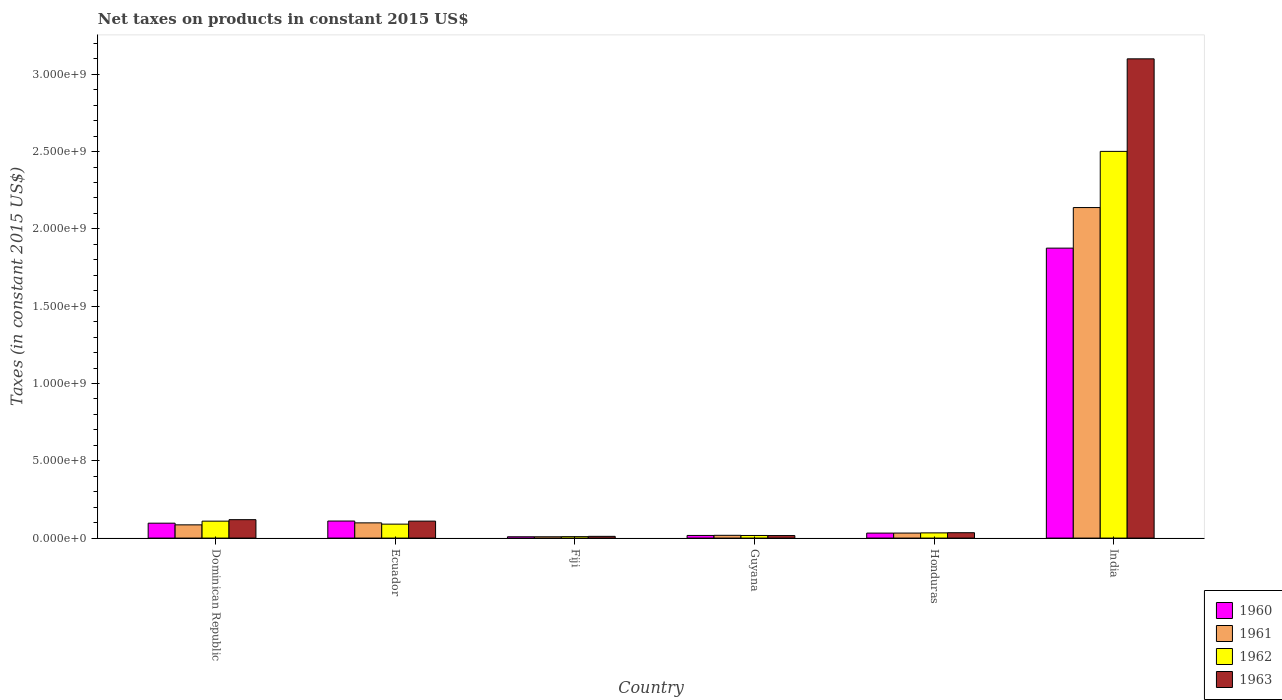How many different coloured bars are there?
Your answer should be compact. 4. How many groups of bars are there?
Your response must be concise. 6. Are the number of bars on each tick of the X-axis equal?
Provide a succinct answer. Yes. What is the label of the 5th group of bars from the left?
Provide a succinct answer. Honduras. In how many cases, is the number of bars for a given country not equal to the number of legend labels?
Provide a short and direct response. 0. What is the net taxes on products in 1962 in Fiji?
Give a very brief answer. 9.32e+06. Across all countries, what is the maximum net taxes on products in 1960?
Make the answer very short. 1.88e+09. Across all countries, what is the minimum net taxes on products in 1961?
Give a very brief answer. 8.56e+06. In which country was the net taxes on products in 1963 minimum?
Ensure brevity in your answer.  Fiji. What is the total net taxes on products in 1960 in the graph?
Make the answer very short. 2.14e+09. What is the difference between the net taxes on products in 1962 in Guyana and that in Honduras?
Provide a succinct answer. -1.67e+07. What is the difference between the net taxes on products in 1960 in Honduras and the net taxes on products in 1961 in Fiji?
Provide a short and direct response. 2.37e+07. What is the average net taxes on products in 1960 per country?
Provide a succinct answer. 3.57e+08. What is the difference between the net taxes on products of/in 1960 and net taxes on products of/in 1963 in Ecuador?
Your response must be concise. 5.57e+05. What is the ratio of the net taxes on products in 1962 in Dominican Republic to that in Fiji?
Provide a succinct answer. 11.76. Is the net taxes on products in 1960 in Fiji less than that in Guyana?
Offer a terse response. Yes. Is the difference between the net taxes on products in 1960 in Fiji and Honduras greater than the difference between the net taxes on products in 1963 in Fiji and Honduras?
Your answer should be very brief. No. What is the difference between the highest and the second highest net taxes on products in 1960?
Provide a succinct answer. -1.78e+09. What is the difference between the highest and the lowest net taxes on products in 1962?
Your answer should be very brief. 2.49e+09. What does the 4th bar from the right in Dominican Republic represents?
Your answer should be very brief. 1960. How many countries are there in the graph?
Provide a short and direct response. 6. What is the difference between two consecutive major ticks on the Y-axis?
Make the answer very short. 5.00e+08. Are the values on the major ticks of Y-axis written in scientific E-notation?
Make the answer very short. Yes. Does the graph contain grids?
Offer a very short reply. No. How are the legend labels stacked?
Your answer should be compact. Vertical. What is the title of the graph?
Offer a terse response. Net taxes on products in constant 2015 US$. Does "1980" appear as one of the legend labels in the graph?
Offer a terse response. No. What is the label or title of the Y-axis?
Offer a terse response. Taxes (in constant 2015 US$). What is the Taxes (in constant 2015 US$) in 1960 in Dominican Republic?
Offer a very short reply. 9.64e+07. What is the Taxes (in constant 2015 US$) in 1961 in Dominican Republic?
Provide a short and direct response. 8.56e+07. What is the Taxes (in constant 2015 US$) in 1962 in Dominican Republic?
Offer a very short reply. 1.10e+08. What is the Taxes (in constant 2015 US$) in 1963 in Dominican Republic?
Offer a terse response. 1.19e+08. What is the Taxes (in constant 2015 US$) of 1960 in Ecuador?
Provide a succinct answer. 1.10e+08. What is the Taxes (in constant 2015 US$) in 1961 in Ecuador?
Provide a short and direct response. 9.85e+07. What is the Taxes (in constant 2015 US$) in 1962 in Ecuador?
Ensure brevity in your answer.  9.03e+07. What is the Taxes (in constant 2015 US$) in 1963 in Ecuador?
Ensure brevity in your answer.  1.10e+08. What is the Taxes (in constant 2015 US$) of 1960 in Fiji?
Make the answer very short. 8.56e+06. What is the Taxes (in constant 2015 US$) of 1961 in Fiji?
Offer a very short reply. 8.56e+06. What is the Taxes (in constant 2015 US$) of 1962 in Fiji?
Your answer should be very brief. 9.32e+06. What is the Taxes (in constant 2015 US$) of 1963 in Fiji?
Give a very brief answer. 1.12e+07. What is the Taxes (in constant 2015 US$) of 1960 in Guyana?
Give a very brief answer. 1.71e+07. What is the Taxes (in constant 2015 US$) in 1961 in Guyana?
Keep it short and to the point. 1.79e+07. What is the Taxes (in constant 2015 US$) of 1962 in Guyana?
Provide a short and direct response. 1.69e+07. What is the Taxes (in constant 2015 US$) of 1963 in Guyana?
Offer a very short reply. 1.64e+07. What is the Taxes (in constant 2015 US$) of 1960 in Honduras?
Ensure brevity in your answer.  3.22e+07. What is the Taxes (in constant 2015 US$) in 1961 in Honduras?
Your response must be concise. 3.25e+07. What is the Taxes (in constant 2015 US$) in 1962 in Honduras?
Make the answer very short. 3.36e+07. What is the Taxes (in constant 2015 US$) of 1963 in Honduras?
Offer a terse response. 3.48e+07. What is the Taxes (in constant 2015 US$) of 1960 in India?
Make the answer very short. 1.88e+09. What is the Taxes (in constant 2015 US$) of 1961 in India?
Make the answer very short. 2.14e+09. What is the Taxes (in constant 2015 US$) of 1962 in India?
Give a very brief answer. 2.50e+09. What is the Taxes (in constant 2015 US$) in 1963 in India?
Keep it short and to the point. 3.10e+09. Across all countries, what is the maximum Taxes (in constant 2015 US$) of 1960?
Your response must be concise. 1.88e+09. Across all countries, what is the maximum Taxes (in constant 2015 US$) in 1961?
Make the answer very short. 2.14e+09. Across all countries, what is the maximum Taxes (in constant 2015 US$) in 1962?
Provide a succinct answer. 2.50e+09. Across all countries, what is the maximum Taxes (in constant 2015 US$) of 1963?
Provide a short and direct response. 3.10e+09. Across all countries, what is the minimum Taxes (in constant 2015 US$) of 1960?
Make the answer very short. 8.56e+06. Across all countries, what is the minimum Taxes (in constant 2015 US$) in 1961?
Give a very brief answer. 8.56e+06. Across all countries, what is the minimum Taxes (in constant 2015 US$) in 1962?
Offer a very short reply. 9.32e+06. Across all countries, what is the minimum Taxes (in constant 2015 US$) of 1963?
Keep it short and to the point. 1.12e+07. What is the total Taxes (in constant 2015 US$) of 1960 in the graph?
Provide a succinct answer. 2.14e+09. What is the total Taxes (in constant 2015 US$) in 1961 in the graph?
Provide a succinct answer. 2.38e+09. What is the total Taxes (in constant 2015 US$) in 1962 in the graph?
Your answer should be compact. 2.76e+09. What is the total Taxes (in constant 2015 US$) in 1963 in the graph?
Provide a succinct answer. 3.39e+09. What is the difference between the Taxes (in constant 2015 US$) in 1960 in Dominican Republic and that in Ecuador?
Your response must be concise. -1.39e+07. What is the difference between the Taxes (in constant 2015 US$) of 1961 in Dominican Republic and that in Ecuador?
Your answer should be compact. -1.29e+07. What is the difference between the Taxes (in constant 2015 US$) in 1962 in Dominican Republic and that in Ecuador?
Keep it short and to the point. 1.93e+07. What is the difference between the Taxes (in constant 2015 US$) in 1963 in Dominican Republic and that in Ecuador?
Provide a succinct answer. 9.44e+06. What is the difference between the Taxes (in constant 2015 US$) in 1960 in Dominican Republic and that in Fiji?
Make the answer very short. 8.78e+07. What is the difference between the Taxes (in constant 2015 US$) in 1961 in Dominican Republic and that in Fiji?
Give a very brief answer. 7.70e+07. What is the difference between the Taxes (in constant 2015 US$) of 1962 in Dominican Republic and that in Fiji?
Give a very brief answer. 1.00e+08. What is the difference between the Taxes (in constant 2015 US$) in 1963 in Dominican Republic and that in Fiji?
Provide a short and direct response. 1.08e+08. What is the difference between the Taxes (in constant 2015 US$) of 1960 in Dominican Republic and that in Guyana?
Offer a terse response. 7.93e+07. What is the difference between the Taxes (in constant 2015 US$) in 1961 in Dominican Republic and that in Guyana?
Give a very brief answer. 6.77e+07. What is the difference between the Taxes (in constant 2015 US$) in 1962 in Dominican Republic and that in Guyana?
Keep it short and to the point. 9.27e+07. What is the difference between the Taxes (in constant 2015 US$) in 1963 in Dominican Republic and that in Guyana?
Your response must be concise. 1.03e+08. What is the difference between the Taxes (in constant 2015 US$) of 1960 in Dominican Republic and that in Honduras?
Your response must be concise. 6.42e+07. What is the difference between the Taxes (in constant 2015 US$) of 1961 in Dominican Republic and that in Honduras?
Offer a terse response. 5.31e+07. What is the difference between the Taxes (in constant 2015 US$) of 1962 in Dominican Republic and that in Honduras?
Your answer should be very brief. 7.60e+07. What is the difference between the Taxes (in constant 2015 US$) in 1963 in Dominican Republic and that in Honduras?
Offer a very short reply. 8.44e+07. What is the difference between the Taxes (in constant 2015 US$) in 1960 in Dominican Republic and that in India?
Make the answer very short. -1.78e+09. What is the difference between the Taxes (in constant 2015 US$) in 1961 in Dominican Republic and that in India?
Your response must be concise. -2.05e+09. What is the difference between the Taxes (in constant 2015 US$) in 1962 in Dominican Republic and that in India?
Give a very brief answer. -2.39e+09. What is the difference between the Taxes (in constant 2015 US$) of 1963 in Dominican Republic and that in India?
Provide a short and direct response. -2.98e+09. What is the difference between the Taxes (in constant 2015 US$) in 1960 in Ecuador and that in Fiji?
Your answer should be very brief. 1.02e+08. What is the difference between the Taxes (in constant 2015 US$) in 1961 in Ecuador and that in Fiji?
Keep it short and to the point. 8.99e+07. What is the difference between the Taxes (in constant 2015 US$) in 1962 in Ecuador and that in Fiji?
Offer a terse response. 8.09e+07. What is the difference between the Taxes (in constant 2015 US$) of 1963 in Ecuador and that in Fiji?
Ensure brevity in your answer.  9.86e+07. What is the difference between the Taxes (in constant 2015 US$) in 1960 in Ecuador and that in Guyana?
Offer a very short reply. 9.32e+07. What is the difference between the Taxes (in constant 2015 US$) of 1961 in Ecuador and that in Guyana?
Keep it short and to the point. 8.06e+07. What is the difference between the Taxes (in constant 2015 US$) of 1962 in Ecuador and that in Guyana?
Offer a terse response. 7.33e+07. What is the difference between the Taxes (in constant 2015 US$) in 1963 in Ecuador and that in Guyana?
Provide a succinct answer. 9.33e+07. What is the difference between the Taxes (in constant 2015 US$) in 1960 in Ecuador and that in Honduras?
Provide a short and direct response. 7.81e+07. What is the difference between the Taxes (in constant 2015 US$) in 1961 in Ecuador and that in Honduras?
Offer a very short reply. 6.60e+07. What is the difference between the Taxes (in constant 2015 US$) in 1962 in Ecuador and that in Honduras?
Your answer should be very brief. 5.66e+07. What is the difference between the Taxes (in constant 2015 US$) in 1963 in Ecuador and that in Honduras?
Your answer should be compact. 7.50e+07. What is the difference between the Taxes (in constant 2015 US$) in 1960 in Ecuador and that in India?
Offer a terse response. -1.76e+09. What is the difference between the Taxes (in constant 2015 US$) of 1961 in Ecuador and that in India?
Your answer should be compact. -2.04e+09. What is the difference between the Taxes (in constant 2015 US$) of 1962 in Ecuador and that in India?
Offer a terse response. -2.41e+09. What is the difference between the Taxes (in constant 2015 US$) in 1963 in Ecuador and that in India?
Provide a short and direct response. -2.99e+09. What is the difference between the Taxes (in constant 2015 US$) in 1960 in Fiji and that in Guyana?
Your answer should be compact. -8.59e+06. What is the difference between the Taxes (in constant 2015 US$) of 1961 in Fiji and that in Guyana?
Ensure brevity in your answer.  -9.34e+06. What is the difference between the Taxes (in constant 2015 US$) of 1962 in Fiji and that in Guyana?
Offer a very short reply. -7.60e+06. What is the difference between the Taxes (in constant 2015 US$) of 1963 in Fiji and that in Guyana?
Ensure brevity in your answer.  -5.24e+06. What is the difference between the Taxes (in constant 2015 US$) of 1960 in Fiji and that in Honduras?
Give a very brief answer. -2.37e+07. What is the difference between the Taxes (in constant 2015 US$) in 1961 in Fiji and that in Honduras?
Offer a terse response. -2.39e+07. What is the difference between the Taxes (in constant 2015 US$) of 1962 in Fiji and that in Honduras?
Provide a short and direct response. -2.43e+07. What is the difference between the Taxes (in constant 2015 US$) in 1963 in Fiji and that in Honduras?
Ensure brevity in your answer.  -2.36e+07. What is the difference between the Taxes (in constant 2015 US$) of 1960 in Fiji and that in India?
Provide a short and direct response. -1.87e+09. What is the difference between the Taxes (in constant 2015 US$) in 1961 in Fiji and that in India?
Ensure brevity in your answer.  -2.13e+09. What is the difference between the Taxes (in constant 2015 US$) in 1962 in Fiji and that in India?
Ensure brevity in your answer.  -2.49e+09. What is the difference between the Taxes (in constant 2015 US$) of 1963 in Fiji and that in India?
Offer a terse response. -3.09e+09. What is the difference between the Taxes (in constant 2015 US$) of 1960 in Guyana and that in Honduras?
Your answer should be compact. -1.51e+07. What is the difference between the Taxes (in constant 2015 US$) in 1961 in Guyana and that in Honduras?
Your answer should be compact. -1.46e+07. What is the difference between the Taxes (in constant 2015 US$) of 1962 in Guyana and that in Honduras?
Your response must be concise. -1.67e+07. What is the difference between the Taxes (in constant 2015 US$) of 1963 in Guyana and that in Honduras?
Provide a succinct answer. -1.84e+07. What is the difference between the Taxes (in constant 2015 US$) in 1960 in Guyana and that in India?
Provide a short and direct response. -1.86e+09. What is the difference between the Taxes (in constant 2015 US$) in 1961 in Guyana and that in India?
Your answer should be very brief. -2.12e+09. What is the difference between the Taxes (in constant 2015 US$) in 1962 in Guyana and that in India?
Your answer should be compact. -2.48e+09. What is the difference between the Taxes (in constant 2015 US$) in 1963 in Guyana and that in India?
Your answer should be very brief. -3.08e+09. What is the difference between the Taxes (in constant 2015 US$) of 1960 in Honduras and that in India?
Give a very brief answer. -1.84e+09. What is the difference between the Taxes (in constant 2015 US$) of 1961 in Honduras and that in India?
Provide a short and direct response. -2.11e+09. What is the difference between the Taxes (in constant 2015 US$) in 1962 in Honduras and that in India?
Offer a very short reply. -2.47e+09. What is the difference between the Taxes (in constant 2015 US$) in 1963 in Honduras and that in India?
Your response must be concise. -3.06e+09. What is the difference between the Taxes (in constant 2015 US$) in 1960 in Dominican Republic and the Taxes (in constant 2015 US$) in 1961 in Ecuador?
Ensure brevity in your answer.  -2.07e+06. What is the difference between the Taxes (in constant 2015 US$) of 1960 in Dominican Republic and the Taxes (in constant 2015 US$) of 1962 in Ecuador?
Your response must be concise. 6.14e+06. What is the difference between the Taxes (in constant 2015 US$) in 1960 in Dominican Republic and the Taxes (in constant 2015 US$) in 1963 in Ecuador?
Offer a terse response. -1.34e+07. What is the difference between the Taxes (in constant 2015 US$) of 1961 in Dominican Republic and the Taxes (in constant 2015 US$) of 1962 in Ecuador?
Your answer should be compact. -4.66e+06. What is the difference between the Taxes (in constant 2015 US$) in 1961 in Dominican Republic and the Taxes (in constant 2015 US$) in 1963 in Ecuador?
Make the answer very short. -2.42e+07. What is the difference between the Taxes (in constant 2015 US$) in 1962 in Dominican Republic and the Taxes (in constant 2015 US$) in 1963 in Ecuador?
Provide a short and direct response. -1.64e+05. What is the difference between the Taxes (in constant 2015 US$) in 1960 in Dominican Republic and the Taxes (in constant 2015 US$) in 1961 in Fiji?
Your response must be concise. 8.78e+07. What is the difference between the Taxes (in constant 2015 US$) in 1960 in Dominican Republic and the Taxes (in constant 2015 US$) in 1962 in Fiji?
Ensure brevity in your answer.  8.71e+07. What is the difference between the Taxes (in constant 2015 US$) of 1960 in Dominican Republic and the Taxes (in constant 2015 US$) of 1963 in Fiji?
Your answer should be compact. 8.52e+07. What is the difference between the Taxes (in constant 2015 US$) of 1961 in Dominican Republic and the Taxes (in constant 2015 US$) of 1962 in Fiji?
Your answer should be compact. 7.63e+07. What is the difference between the Taxes (in constant 2015 US$) of 1961 in Dominican Republic and the Taxes (in constant 2015 US$) of 1963 in Fiji?
Offer a terse response. 7.44e+07. What is the difference between the Taxes (in constant 2015 US$) in 1962 in Dominican Republic and the Taxes (in constant 2015 US$) in 1963 in Fiji?
Ensure brevity in your answer.  9.84e+07. What is the difference between the Taxes (in constant 2015 US$) of 1960 in Dominican Republic and the Taxes (in constant 2015 US$) of 1961 in Guyana?
Offer a terse response. 7.85e+07. What is the difference between the Taxes (in constant 2015 US$) of 1960 in Dominican Republic and the Taxes (in constant 2015 US$) of 1962 in Guyana?
Offer a very short reply. 7.95e+07. What is the difference between the Taxes (in constant 2015 US$) in 1960 in Dominican Republic and the Taxes (in constant 2015 US$) in 1963 in Guyana?
Ensure brevity in your answer.  8.00e+07. What is the difference between the Taxes (in constant 2015 US$) in 1961 in Dominican Republic and the Taxes (in constant 2015 US$) in 1962 in Guyana?
Keep it short and to the point. 6.87e+07. What is the difference between the Taxes (in constant 2015 US$) of 1961 in Dominican Republic and the Taxes (in constant 2015 US$) of 1963 in Guyana?
Your answer should be very brief. 6.92e+07. What is the difference between the Taxes (in constant 2015 US$) of 1962 in Dominican Republic and the Taxes (in constant 2015 US$) of 1963 in Guyana?
Make the answer very short. 9.32e+07. What is the difference between the Taxes (in constant 2015 US$) in 1960 in Dominican Republic and the Taxes (in constant 2015 US$) in 1961 in Honduras?
Provide a short and direct response. 6.39e+07. What is the difference between the Taxes (in constant 2015 US$) of 1960 in Dominican Republic and the Taxes (in constant 2015 US$) of 1962 in Honduras?
Provide a short and direct response. 6.28e+07. What is the difference between the Taxes (in constant 2015 US$) in 1960 in Dominican Republic and the Taxes (in constant 2015 US$) in 1963 in Honduras?
Your response must be concise. 6.16e+07. What is the difference between the Taxes (in constant 2015 US$) of 1961 in Dominican Republic and the Taxes (in constant 2015 US$) of 1962 in Honduras?
Your answer should be compact. 5.20e+07. What is the difference between the Taxes (in constant 2015 US$) of 1961 in Dominican Republic and the Taxes (in constant 2015 US$) of 1963 in Honduras?
Your response must be concise. 5.08e+07. What is the difference between the Taxes (in constant 2015 US$) of 1962 in Dominican Republic and the Taxes (in constant 2015 US$) of 1963 in Honduras?
Provide a succinct answer. 7.48e+07. What is the difference between the Taxes (in constant 2015 US$) in 1960 in Dominican Republic and the Taxes (in constant 2015 US$) in 1961 in India?
Offer a terse response. -2.04e+09. What is the difference between the Taxes (in constant 2015 US$) in 1960 in Dominican Republic and the Taxes (in constant 2015 US$) in 1962 in India?
Provide a succinct answer. -2.40e+09. What is the difference between the Taxes (in constant 2015 US$) of 1960 in Dominican Republic and the Taxes (in constant 2015 US$) of 1963 in India?
Your response must be concise. -3.00e+09. What is the difference between the Taxes (in constant 2015 US$) of 1961 in Dominican Republic and the Taxes (in constant 2015 US$) of 1962 in India?
Ensure brevity in your answer.  -2.42e+09. What is the difference between the Taxes (in constant 2015 US$) in 1961 in Dominican Republic and the Taxes (in constant 2015 US$) in 1963 in India?
Make the answer very short. -3.01e+09. What is the difference between the Taxes (in constant 2015 US$) of 1962 in Dominican Republic and the Taxes (in constant 2015 US$) of 1963 in India?
Offer a very short reply. -2.99e+09. What is the difference between the Taxes (in constant 2015 US$) of 1960 in Ecuador and the Taxes (in constant 2015 US$) of 1961 in Fiji?
Your answer should be compact. 1.02e+08. What is the difference between the Taxes (in constant 2015 US$) in 1960 in Ecuador and the Taxes (in constant 2015 US$) in 1962 in Fiji?
Offer a very short reply. 1.01e+08. What is the difference between the Taxes (in constant 2015 US$) in 1960 in Ecuador and the Taxes (in constant 2015 US$) in 1963 in Fiji?
Your response must be concise. 9.91e+07. What is the difference between the Taxes (in constant 2015 US$) of 1961 in Ecuador and the Taxes (in constant 2015 US$) of 1962 in Fiji?
Provide a succinct answer. 8.91e+07. What is the difference between the Taxes (in constant 2015 US$) of 1961 in Ecuador and the Taxes (in constant 2015 US$) of 1963 in Fiji?
Make the answer very short. 8.73e+07. What is the difference between the Taxes (in constant 2015 US$) in 1962 in Ecuador and the Taxes (in constant 2015 US$) in 1963 in Fiji?
Provide a succinct answer. 7.91e+07. What is the difference between the Taxes (in constant 2015 US$) of 1960 in Ecuador and the Taxes (in constant 2015 US$) of 1961 in Guyana?
Offer a terse response. 9.24e+07. What is the difference between the Taxes (in constant 2015 US$) of 1960 in Ecuador and the Taxes (in constant 2015 US$) of 1962 in Guyana?
Provide a succinct answer. 9.34e+07. What is the difference between the Taxes (in constant 2015 US$) in 1960 in Ecuador and the Taxes (in constant 2015 US$) in 1963 in Guyana?
Your answer should be compact. 9.39e+07. What is the difference between the Taxes (in constant 2015 US$) in 1961 in Ecuador and the Taxes (in constant 2015 US$) in 1962 in Guyana?
Offer a terse response. 8.16e+07. What is the difference between the Taxes (in constant 2015 US$) of 1961 in Ecuador and the Taxes (in constant 2015 US$) of 1963 in Guyana?
Make the answer very short. 8.20e+07. What is the difference between the Taxes (in constant 2015 US$) in 1962 in Ecuador and the Taxes (in constant 2015 US$) in 1963 in Guyana?
Ensure brevity in your answer.  7.38e+07. What is the difference between the Taxes (in constant 2015 US$) in 1960 in Ecuador and the Taxes (in constant 2015 US$) in 1961 in Honduras?
Your response must be concise. 7.78e+07. What is the difference between the Taxes (in constant 2015 US$) of 1960 in Ecuador and the Taxes (in constant 2015 US$) of 1962 in Honduras?
Ensure brevity in your answer.  7.67e+07. What is the difference between the Taxes (in constant 2015 US$) of 1960 in Ecuador and the Taxes (in constant 2015 US$) of 1963 in Honduras?
Your answer should be very brief. 7.55e+07. What is the difference between the Taxes (in constant 2015 US$) of 1961 in Ecuador and the Taxes (in constant 2015 US$) of 1962 in Honduras?
Ensure brevity in your answer.  6.48e+07. What is the difference between the Taxes (in constant 2015 US$) in 1961 in Ecuador and the Taxes (in constant 2015 US$) in 1963 in Honduras?
Your answer should be very brief. 6.37e+07. What is the difference between the Taxes (in constant 2015 US$) in 1962 in Ecuador and the Taxes (in constant 2015 US$) in 1963 in Honduras?
Ensure brevity in your answer.  5.55e+07. What is the difference between the Taxes (in constant 2015 US$) of 1960 in Ecuador and the Taxes (in constant 2015 US$) of 1961 in India?
Provide a succinct answer. -2.03e+09. What is the difference between the Taxes (in constant 2015 US$) in 1960 in Ecuador and the Taxes (in constant 2015 US$) in 1962 in India?
Provide a short and direct response. -2.39e+09. What is the difference between the Taxes (in constant 2015 US$) in 1960 in Ecuador and the Taxes (in constant 2015 US$) in 1963 in India?
Provide a succinct answer. -2.99e+09. What is the difference between the Taxes (in constant 2015 US$) of 1961 in Ecuador and the Taxes (in constant 2015 US$) of 1962 in India?
Your answer should be very brief. -2.40e+09. What is the difference between the Taxes (in constant 2015 US$) of 1961 in Ecuador and the Taxes (in constant 2015 US$) of 1963 in India?
Provide a succinct answer. -3.00e+09. What is the difference between the Taxes (in constant 2015 US$) of 1962 in Ecuador and the Taxes (in constant 2015 US$) of 1963 in India?
Provide a short and direct response. -3.01e+09. What is the difference between the Taxes (in constant 2015 US$) of 1960 in Fiji and the Taxes (in constant 2015 US$) of 1961 in Guyana?
Make the answer very short. -9.34e+06. What is the difference between the Taxes (in constant 2015 US$) in 1960 in Fiji and the Taxes (in constant 2015 US$) in 1962 in Guyana?
Your answer should be compact. -8.35e+06. What is the difference between the Taxes (in constant 2015 US$) of 1960 in Fiji and the Taxes (in constant 2015 US$) of 1963 in Guyana?
Provide a succinct answer. -7.89e+06. What is the difference between the Taxes (in constant 2015 US$) in 1961 in Fiji and the Taxes (in constant 2015 US$) in 1962 in Guyana?
Offer a terse response. -8.35e+06. What is the difference between the Taxes (in constant 2015 US$) in 1961 in Fiji and the Taxes (in constant 2015 US$) in 1963 in Guyana?
Provide a succinct answer. -7.89e+06. What is the difference between the Taxes (in constant 2015 US$) of 1962 in Fiji and the Taxes (in constant 2015 US$) of 1963 in Guyana?
Keep it short and to the point. -7.13e+06. What is the difference between the Taxes (in constant 2015 US$) of 1960 in Fiji and the Taxes (in constant 2015 US$) of 1961 in Honduras?
Make the answer very short. -2.39e+07. What is the difference between the Taxes (in constant 2015 US$) of 1960 in Fiji and the Taxes (in constant 2015 US$) of 1962 in Honduras?
Keep it short and to the point. -2.51e+07. What is the difference between the Taxes (in constant 2015 US$) of 1960 in Fiji and the Taxes (in constant 2015 US$) of 1963 in Honduras?
Your answer should be very brief. -2.62e+07. What is the difference between the Taxes (in constant 2015 US$) of 1961 in Fiji and the Taxes (in constant 2015 US$) of 1962 in Honduras?
Your answer should be compact. -2.51e+07. What is the difference between the Taxes (in constant 2015 US$) of 1961 in Fiji and the Taxes (in constant 2015 US$) of 1963 in Honduras?
Provide a short and direct response. -2.62e+07. What is the difference between the Taxes (in constant 2015 US$) of 1962 in Fiji and the Taxes (in constant 2015 US$) of 1963 in Honduras?
Give a very brief answer. -2.55e+07. What is the difference between the Taxes (in constant 2015 US$) in 1960 in Fiji and the Taxes (in constant 2015 US$) in 1961 in India?
Keep it short and to the point. -2.13e+09. What is the difference between the Taxes (in constant 2015 US$) of 1960 in Fiji and the Taxes (in constant 2015 US$) of 1962 in India?
Offer a terse response. -2.49e+09. What is the difference between the Taxes (in constant 2015 US$) in 1960 in Fiji and the Taxes (in constant 2015 US$) in 1963 in India?
Keep it short and to the point. -3.09e+09. What is the difference between the Taxes (in constant 2015 US$) of 1961 in Fiji and the Taxes (in constant 2015 US$) of 1962 in India?
Make the answer very short. -2.49e+09. What is the difference between the Taxes (in constant 2015 US$) of 1961 in Fiji and the Taxes (in constant 2015 US$) of 1963 in India?
Your response must be concise. -3.09e+09. What is the difference between the Taxes (in constant 2015 US$) in 1962 in Fiji and the Taxes (in constant 2015 US$) in 1963 in India?
Ensure brevity in your answer.  -3.09e+09. What is the difference between the Taxes (in constant 2015 US$) in 1960 in Guyana and the Taxes (in constant 2015 US$) in 1961 in Honduras?
Keep it short and to the point. -1.54e+07. What is the difference between the Taxes (in constant 2015 US$) in 1960 in Guyana and the Taxes (in constant 2015 US$) in 1962 in Honduras?
Give a very brief answer. -1.65e+07. What is the difference between the Taxes (in constant 2015 US$) of 1960 in Guyana and the Taxes (in constant 2015 US$) of 1963 in Honduras?
Your answer should be very brief. -1.77e+07. What is the difference between the Taxes (in constant 2015 US$) in 1961 in Guyana and the Taxes (in constant 2015 US$) in 1962 in Honduras?
Your answer should be compact. -1.57e+07. What is the difference between the Taxes (in constant 2015 US$) in 1961 in Guyana and the Taxes (in constant 2015 US$) in 1963 in Honduras?
Ensure brevity in your answer.  -1.69e+07. What is the difference between the Taxes (in constant 2015 US$) of 1962 in Guyana and the Taxes (in constant 2015 US$) of 1963 in Honduras?
Keep it short and to the point. -1.79e+07. What is the difference between the Taxes (in constant 2015 US$) in 1960 in Guyana and the Taxes (in constant 2015 US$) in 1961 in India?
Give a very brief answer. -2.12e+09. What is the difference between the Taxes (in constant 2015 US$) in 1960 in Guyana and the Taxes (in constant 2015 US$) in 1962 in India?
Your response must be concise. -2.48e+09. What is the difference between the Taxes (in constant 2015 US$) of 1960 in Guyana and the Taxes (in constant 2015 US$) of 1963 in India?
Your response must be concise. -3.08e+09. What is the difference between the Taxes (in constant 2015 US$) in 1961 in Guyana and the Taxes (in constant 2015 US$) in 1962 in India?
Your response must be concise. -2.48e+09. What is the difference between the Taxes (in constant 2015 US$) of 1961 in Guyana and the Taxes (in constant 2015 US$) of 1963 in India?
Provide a short and direct response. -3.08e+09. What is the difference between the Taxes (in constant 2015 US$) in 1962 in Guyana and the Taxes (in constant 2015 US$) in 1963 in India?
Provide a short and direct response. -3.08e+09. What is the difference between the Taxes (in constant 2015 US$) in 1960 in Honduras and the Taxes (in constant 2015 US$) in 1961 in India?
Ensure brevity in your answer.  -2.11e+09. What is the difference between the Taxes (in constant 2015 US$) of 1960 in Honduras and the Taxes (in constant 2015 US$) of 1962 in India?
Offer a very short reply. -2.47e+09. What is the difference between the Taxes (in constant 2015 US$) of 1960 in Honduras and the Taxes (in constant 2015 US$) of 1963 in India?
Keep it short and to the point. -3.07e+09. What is the difference between the Taxes (in constant 2015 US$) in 1961 in Honduras and the Taxes (in constant 2015 US$) in 1962 in India?
Ensure brevity in your answer.  -2.47e+09. What is the difference between the Taxes (in constant 2015 US$) in 1961 in Honduras and the Taxes (in constant 2015 US$) in 1963 in India?
Provide a succinct answer. -3.07e+09. What is the difference between the Taxes (in constant 2015 US$) in 1962 in Honduras and the Taxes (in constant 2015 US$) in 1963 in India?
Your answer should be very brief. -3.07e+09. What is the average Taxes (in constant 2015 US$) in 1960 per country?
Provide a succinct answer. 3.57e+08. What is the average Taxes (in constant 2015 US$) in 1961 per country?
Make the answer very short. 3.97e+08. What is the average Taxes (in constant 2015 US$) in 1962 per country?
Keep it short and to the point. 4.60e+08. What is the average Taxes (in constant 2015 US$) of 1963 per country?
Give a very brief answer. 5.65e+08. What is the difference between the Taxes (in constant 2015 US$) in 1960 and Taxes (in constant 2015 US$) in 1961 in Dominican Republic?
Your response must be concise. 1.08e+07. What is the difference between the Taxes (in constant 2015 US$) of 1960 and Taxes (in constant 2015 US$) of 1962 in Dominican Republic?
Your response must be concise. -1.32e+07. What is the difference between the Taxes (in constant 2015 US$) in 1960 and Taxes (in constant 2015 US$) in 1963 in Dominican Republic?
Offer a terse response. -2.28e+07. What is the difference between the Taxes (in constant 2015 US$) in 1961 and Taxes (in constant 2015 US$) in 1962 in Dominican Republic?
Provide a succinct answer. -2.40e+07. What is the difference between the Taxes (in constant 2015 US$) of 1961 and Taxes (in constant 2015 US$) of 1963 in Dominican Republic?
Provide a short and direct response. -3.36e+07. What is the difference between the Taxes (in constant 2015 US$) of 1962 and Taxes (in constant 2015 US$) of 1963 in Dominican Republic?
Your answer should be compact. -9.60e+06. What is the difference between the Taxes (in constant 2015 US$) of 1960 and Taxes (in constant 2015 US$) of 1961 in Ecuador?
Offer a very short reply. 1.19e+07. What is the difference between the Taxes (in constant 2015 US$) of 1960 and Taxes (in constant 2015 US$) of 1962 in Ecuador?
Offer a very short reply. 2.01e+07. What is the difference between the Taxes (in constant 2015 US$) of 1960 and Taxes (in constant 2015 US$) of 1963 in Ecuador?
Offer a very short reply. 5.57e+05. What is the difference between the Taxes (in constant 2015 US$) of 1961 and Taxes (in constant 2015 US$) of 1962 in Ecuador?
Provide a short and direct response. 8.21e+06. What is the difference between the Taxes (in constant 2015 US$) of 1961 and Taxes (in constant 2015 US$) of 1963 in Ecuador?
Provide a succinct answer. -1.13e+07. What is the difference between the Taxes (in constant 2015 US$) of 1962 and Taxes (in constant 2015 US$) of 1963 in Ecuador?
Make the answer very short. -1.95e+07. What is the difference between the Taxes (in constant 2015 US$) in 1960 and Taxes (in constant 2015 US$) in 1962 in Fiji?
Ensure brevity in your answer.  -7.56e+05. What is the difference between the Taxes (in constant 2015 US$) of 1960 and Taxes (in constant 2015 US$) of 1963 in Fiji?
Give a very brief answer. -2.64e+06. What is the difference between the Taxes (in constant 2015 US$) of 1961 and Taxes (in constant 2015 US$) of 1962 in Fiji?
Give a very brief answer. -7.56e+05. What is the difference between the Taxes (in constant 2015 US$) of 1961 and Taxes (in constant 2015 US$) of 1963 in Fiji?
Your answer should be very brief. -2.64e+06. What is the difference between the Taxes (in constant 2015 US$) in 1962 and Taxes (in constant 2015 US$) in 1963 in Fiji?
Provide a succinct answer. -1.89e+06. What is the difference between the Taxes (in constant 2015 US$) in 1960 and Taxes (in constant 2015 US$) in 1961 in Guyana?
Give a very brief answer. -7.58e+05. What is the difference between the Taxes (in constant 2015 US$) in 1960 and Taxes (in constant 2015 US$) in 1962 in Guyana?
Provide a succinct answer. 2.33e+05. What is the difference between the Taxes (in constant 2015 US$) of 1960 and Taxes (in constant 2015 US$) of 1963 in Guyana?
Your response must be concise. 7.00e+05. What is the difference between the Taxes (in constant 2015 US$) of 1961 and Taxes (in constant 2015 US$) of 1962 in Guyana?
Make the answer very short. 9.92e+05. What is the difference between the Taxes (in constant 2015 US$) of 1961 and Taxes (in constant 2015 US$) of 1963 in Guyana?
Your response must be concise. 1.46e+06. What is the difference between the Taxes (in constant 2015 US$) in 1962 and Taxes (in constant 2015 US$) in 1963 in Guyana?
Ensure brevity in your answer.  4.67e+05. What is the difference between the Taxes (in constant 2015 US$) in 1960 and Taxes (in constant 2015 US$) in 1962 in Honduras?
Give a very brief answer. -1.40e+06. What is the difference between the Taxes (in constant 2015 US$) of 1960 and Taxes (in constant 2015 US$) of 1963 in Honduras?
Make the answer very short. -2.55e+06. What is the difference between the Taxes (in constant 2015 US$) of 1961 and Taxes (in constant 2015 US$) of 1962 in Honduras?
Offer a very short reply. -1.15e+06. What is the difference between the Taxes (in constant 2015 US$) of 1961 and Taxes (in constant 2015 US$) of 1963 in Honduras?
Keep it short and to the point. -2.30e+06. What is the difference between the Taxes (in constant 2015 US$) of 1962 and Taxes (in constant 2015 US$) of 1963 in Honduras?
Ensure brevity in your answer.  -1.15e+06. What is the difference between the Taxes (in constant 2015 US$) in 1960 and Taxes (in constant 2015 US$) in 1961 in India?
Ensure brevity in your answer.  -2.63e+08. What is the difference between the Taxes (in constant 2015 US$) in 1960 and Taxes (in constant 2015 US$) in 1962 in India?
Offer a terse response. -6.26e+08. What is the difference between the Taxes (in constant 2015 US$) of 1960 and Taxes (in constant 2015 US$) of 1963 in India?
Your response must be concise. -1.22e+09. What is the difference between the Taxes (in constant 2015 US$) of 1961 and Taxes (in constant 2015 US$) of 1962 in India?
Offer a terse response. -3.63e+08. What is the difference between the Taxes (in constant 2015 US$) in 1961 and Taxes (in constant 2015 US$) in 1963 in India?
Keep it short and to the point. -9.62e+08. What is the difference between the Taxes (in constant 2015 US$) in 1962 and Taxes (in constant 2015 US$) in 1963 in India?
Keep it short and to the point. -5.99e+08. What is the ratio of the Taxes (in constant 2015 US$) in 1960 in Dominican Republic to that in Ecuador?
Your answer should be compact. 0.87. What is the ratio of the Taxes (in constant 2015 US$) in 1961 in Dominican Republic to that in Ecuador?
Provide a succinct answer. 0.87. What is the ratio of the Taxes (in constant 2015 US$) of 1962 in Dominican Republic to that in Ecuador?
Provide a succinct answer. 1.21. What is the ratio of the Taxes (in constant 2015 US$) of 1963 in Dominican Republic to that in Ecuador?
Ensure brevity in your answer.  1.09. What is the ratio of the Taxes (in constant 2015 US$) of 1960 in Dominican Republic to that in Fiji?
Your answer should be very brief. 11.26. What is the ratio of the Taxes (in constant 2015 US$) of 1961 in Dominican Republic to that in Fiji?
Give a very brief answer. 10. What is the ratio of the Taxes (in constant 2015 US$) of 1962 in Dominican Republic to that in Fiji?
Your answer should be compact. 11.76. What is the ratio of the Taxes (in constant 2015 US$) in 1963 in Dominican Republic to that in Fiji?
Offer a terse response. 10.63. What is the ratio of the Taxes (in constant 2015 US$) of 1960 in Dominican Republic to that in Guyana?
Make the answer very short. 5.62. What is the ratio of the Taxes (in constant 2015 US$) of 1961 in Dominican Republic to that in Guyana?
Your answer should be compact. 4.78. What is the ratio of the Taxes (in constant 2015 US$) of 1962 in Dominican Republic to that in Guyana?
Make the answer very short. 6.48. What is the ratio of the Taxes (in constant 2015 US$) in 1963 in Dominican Republic to that in Guyana?
Make the answer very short. 7.25. What is the ratio of the Taxes (in constant 2015 US$) of 1960 in Dominican Republic to that in Honduras?
Your answer should be compact. 2.99. What is the ratio of the Taxes (in constant 2015 US$) in 1961 in Dominican Republic to that in Honduras?
Offer a terse response. 2.63. What is the ratio of the Taxes (in constant 2015 US$) in 1962 in Dominican Republic to that in Honduras?
Keep it short and to the point. 3.26. What is the ratio of the Taxes (in constant 2015 US$) in 1963 in Dominican Republic to that in Honduras?
Make the answer very short. 3.43. What is the ratio of the Taxes (in constant 2015 US$) of 1960 in Dominican Republic to that in India?
Your answer should be very brief. 0.05. What is the ratio of the Taxes (in constant 2015 US$) of 1961 in Dominican Republic to that in India?
Make the answer very short. 0.04. What is the ratio of the Taxes (in constant 2015 US$) of 1962 in Dominican Republic to that in India?
Keep it short and to the point. 0.04. What is the ratio of the Taxes (in constant 2015 US$) of 1963 in Dominican Republic to that in India?
Provide a short and direct response. 0.04. What is the ratio of the Taxes (in constant 2015 US$) in 1960 in Ecuador to that in Fiji?
Your answer should be very brief. 12.88. What is the ratio of the Taxes (in constant 2015 US$) in 1961 in Ecuador to that in Fiji?
Offer a very short reply. 11.5. What is the ratio of the Taxes (in constant 2015 US$) in 1962 in Ecuador to that in Fiji?
Make the answer very short. 9.69. What is the ratio of the Taxes (in constant 2015 US$) in 1963 in Ecuador to that in Fiji?
Provide a succinct answer. 9.79. What is the ratio of the Taxes (in constant 2015 US$) in 1960 in Ecuador to that in Guyana?
Ensure brevity in your answer.  6.43. What is the ratio of the Taxes (in constant 2015 US$) in 1961 in Ecuador to that in Guyana?
Give a very brief answer. 5.5. What is the ratio of the Taxes (in constant 2015 US$) of 1962 in Ecuador to that in Guyana?
Your answer should be compact. 5.34. What is the ratio of the Taxes (in constant 2015 US$) in 1963 in Ecuador to that in Guyana?
Your answer should be compact. 6.67. What is the ratio of the Taxes (in constant 2015 US$) of 1960 in Ecuador to that in Honduras?
Your answer should be compact. 3.42. What is the ratio of the Taxes (in constant 2015 US$) in 1961 in Ecuador to that in Honduras?
Your response must be concise. 3.03. What is the ratio of the Taxes (in constant 2015 US$) in 1962 in Ecuador to that in Honduras?
Offer a terse response. 2.68. What is the ratio of the Taxes (in constant 2015 US$) of 1963 in Ecuador to that in Honduras?
Your answer should be compact. 3.15. What is the ratio of the Taxes (in constant 2015 US$) in 1960 in Ecuador to that in India?
Give a very brief answer. 0.06. What is the ratio of the Taxes (in constant 2015 US$) of 1961 in Ecuador to that in India?
Your answer should be very brief. 0.05. What is the ratio of the Taxes (in constant 2015 US$) in 1962 in Ecuador to that in India?
Your response must be concise. 0.04. What is the ratio of the Taxes (in constant 2015 US$) in 1963 in Ecuador to that in India?
Provide a succinct answer. 0.04. What is the ratio of the Taxes (in constant 2015 US$) in 1960 in Fiji to that in Guyana?
Make the answer very short. 0.5. What is the ratio of the Taxes (in constant 2015 US$) of 1961 in Fiji to that in Guyana?
Give a very brief answer. 0.48. What is the ratio of the Taxes (in constant 2015 US$) in 1962 in Fiji to that in Guyana?
Keep it short and to the point. 0.55. What is the ratio of the Taxes (in constant 2015 US$) of 1963 in Fiji to that in Guyana?
Your answer should be very brief. 0.68. What is the ratio of the Taxes (in constant 2015 US$) in 1960 in Fiji to that in Honduras?
Keep it short and to the point. 0.27. What is the ratio of the Taxes (in constant 2015 US$) of 1961 in Fiji to that in Honduras?
Offer a very short reply. 0.26. What is the ratio of the Taxes (in constant 2015 US$) in 1962 in Fiji to that in Honduras?
Your response must be concise. 0.28. What is the ratio of the Taxes (in constant 2015 US$) of 1963 in Fiji to that in Honduras?
Ensure brevity in your answer.  0.32. What is the ratio of the Taxes (in constant 2015 US$) of 1960 in Fiji to that in India?
Offer a terse response. 0. What is the ratio of the Taxes (in constant 2015 US$) of 1961 in Fiji to that in India?
Give a very brief answer. 0. What is the ratio of the Taxes (in constant 2015 US$) of 1962 in Fiji to that in India?
Make the answer very short. 0. What is the ratio of the Taxes (in constant 2015 US$) of 1963 in Fiji to that in India?
Your response must be concise. 0. What is the ratio of the Taxes (in constant 2015 US$) of 1960 in Guyana to that in Honduras?
Ensure brevity in your answer.  0.53. What is the ratio of the Taxes (in constant 2015 US$) of 1961 in Guyana to that in Honduras?
Offer a very short reply. 0.55. What is the ratio of the Taxes (in constant 2015 US$) of 1962 in Guyana to that in Honduras?
Give a very brief answer. 0.5. What is the ratio of the Taxes (in constant 2015 US$) in 1963 in Guyana to that in Honduras?
Your answer should be very brief. 0.47. What is the ratio of the Taxes (in constant 2015 US$) of 1960 in Guyana to that in India?
Make the answer very short. 0.01. What is the ratio of the Taxes (in constant 2015 US$) of 1961 in Guyana to that in India?
Your answer should be compact. 0.01. What is the ratio of the Taxes (in constant 2015 US$) of 1962 in Guyana to that in India?
Ensure brevity in your answer.  0.01. What is the ratio of the Taxes (in constant 2015 US$) of 1963 in Guyana to that in India?
Offer a very short reply. 0.01. What is the ratio of the Taxes (in constant 2015 US$) in 1960 in Honduras to that in India?
Offer a terse response. 0.02. What is the ratio of the Taxes (in constant 2015 US$) of 1961 in Honduras to that in India?
Make the answer very short. 0.02. What is the ratio of the Taxes (in constant 2015 US$) of 1962 in Honduras to that in India?
Your answer should be compact. 0.01. What is the ratio of the Taxes (in constant 2015 US$) in 1963 in Honduras to that in India?
Provide a short and direct response. 0.01. What is the difference between the highest and the second highest Taxes (in constant 2015 US$) of 1960?
Offer a very short reply. 1.76e+09. What is the difference between the highest and the second highest Taxes (in constant 2015 US$) of 1961?
Ensure brevity in your answer.  2.04e+09. What is the difference between the highest and the second highest Taxes (in constant 2015 US$) in 1962?
Give a very brief answer. 2.39e+09. What is the difference between the highest and the second highest Taxes (in constant 2015 US$) of 1963?
Ensure brevity in your answer.  2.98e+09. What is the difference between the highest and the lowest Taxes (in constant 2015 US$) in 1960?
Your answer should be very brief. 1.87e+09. What is the difference between the highest and the lowest Taxes (in constant 2015 US$) of 1961?
Make the answer very short. 2.13e+09. What is the difference between the highest and the lowest Taxes (in constant 2015 US$) of 1962?
Keep it short and to the point. 2.49e+09. What is the difference between the highest and the lowest Taxes (in constant 2015 US$) in 1963?
Provide a short and direct response. 3.09e+09. 